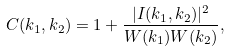Convert formula to latex. <formula><loc_0><loc_0><loc_500><loc_500>C ( { k _ { 1 } } , { k _ { 2 } } ) = 1 + \frac { | I ( { k _ { 1 } } , { k _ { 2 } } ) | ^ { 2 } } { W ( { k _ { 1 } } ) W ( { k _ { 2 } } ) } ,</formula> 